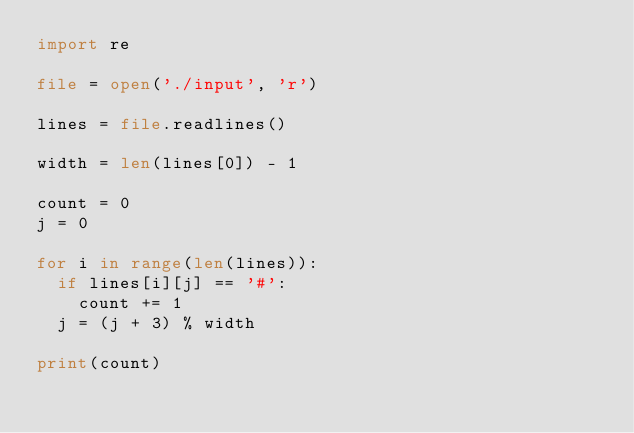Convert code to text. <code><loc_0><loc_0><loc_500><loc_500><_Python_>import re

file = open('./input', 'r')

lines = file.readlines()

width = len(lines[0]) - 1

count = 0
j = 0

for i in range(len(lines)):
  if lines[i][j] == '#':
    count += 1
  j = (j + 3) % width
  
print(count)
</code> 